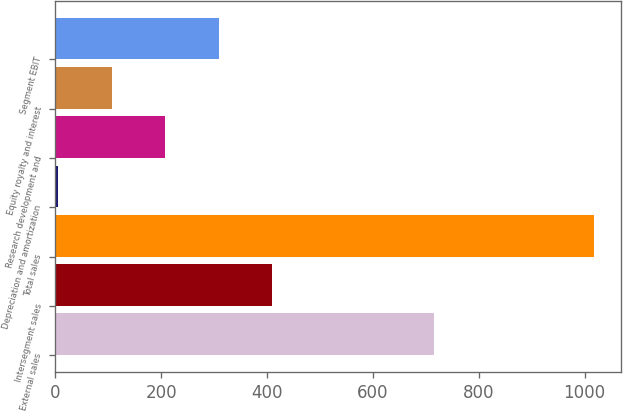<chart> <loc_0><loc_0><loc_500><loc_500><bar_chart><fcel>External sales<fcel>Intersegment sales<fcel>Total sales<fcel>Depreciation and amortization<fcel>Research development and<fcel>Equity royalty and interest<fcel>Segment EBIT<nl><fcel>715<fcel>410.4<fcel>1017<fcel>6<fcel>208.2<fcel>107.1<fcel>309.3<nl></chart> 